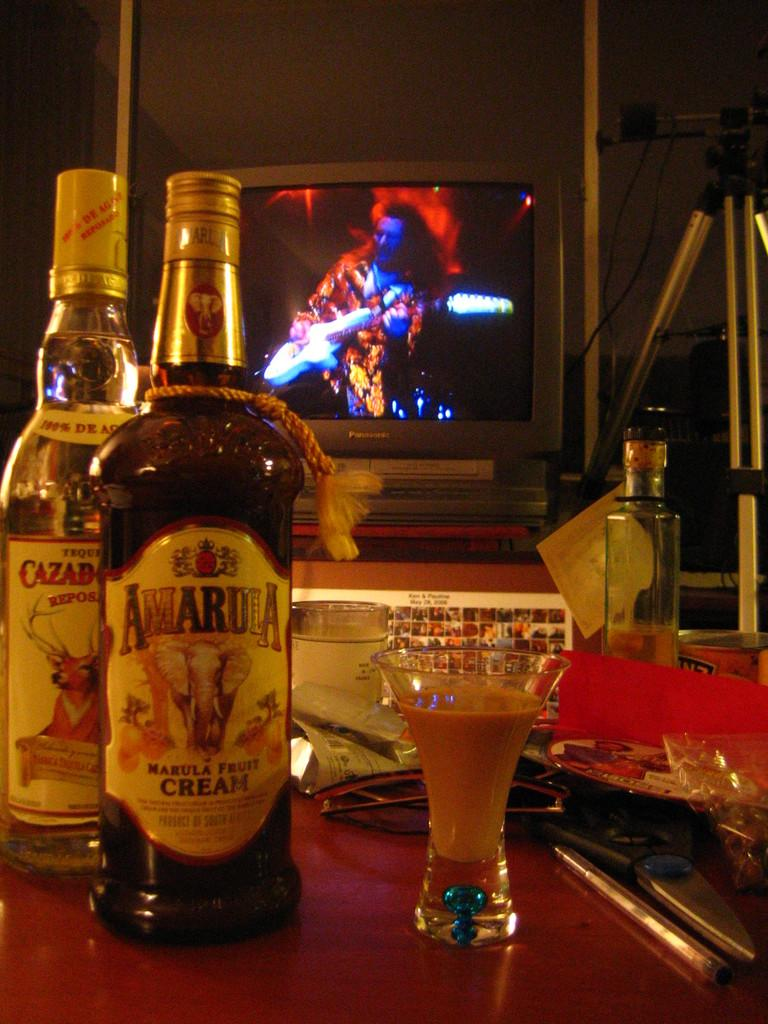Provide a one-sentence caption for the provided image. An unopened bottle of Amarula fruit cream next to a bottle of Tequila. 